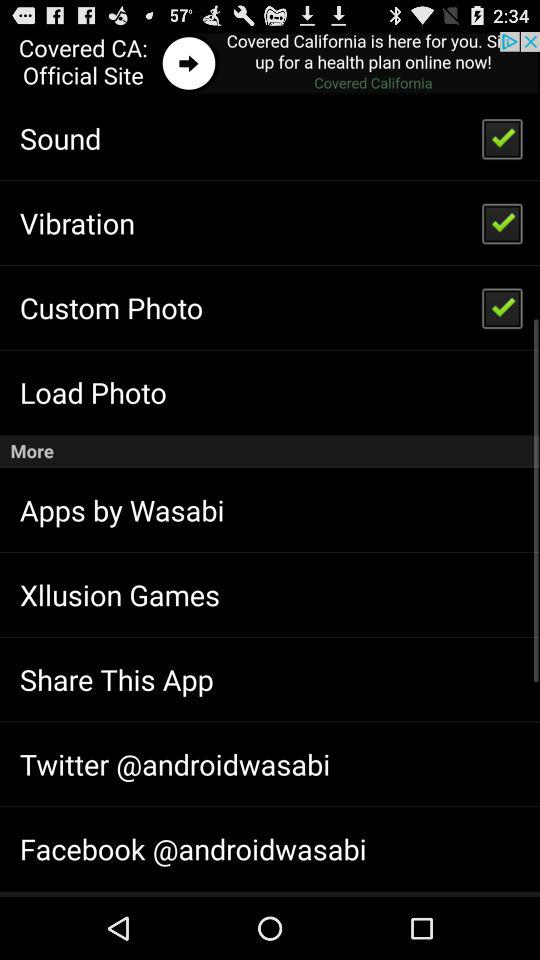What is the status of the "Sound" setting? The status of the "Sound" setting is "on". 